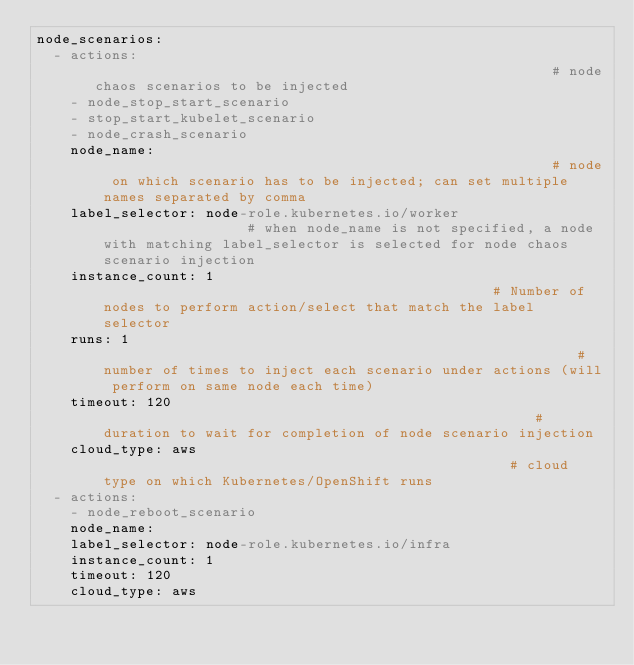Convert code to text. <code><loc_0><loc_0><loc_500><loc_500><_YAML_>node_scenarios:
  - actions:                                                        # node chaos scenarios to be injected
    - node_stop_start_scenario
    - stop_start_kubelet_scenario
    - node_crash_scenario
    node_name:                                                      # node on which scenario has to be injected; can set multiple names separated by comma
    label_selector: node-role.kubernetes.io/worker                  # when node_name is not specified, a node with matching label_selector is selected for node chaos scenario injection
    instance_count: 1                                               # Number of nodes to perform action/select that match the label selector
    runs: 1                                                         # number of times to inject each scenario under actions (will perform on same node each time)
    timeout: 120                                                    # duration to wait for completion of node scenario injection
    cloud_type: aws                                                 # cloud type on which Kubernetes/OpenShift runs
  - actions:
    - node_reboot_scenario
    node_name:
    label_selector: node-role.kubernetes.io/infra
    instance_count: 1
    timeout: 120
    cloud_type: aws
</code> 